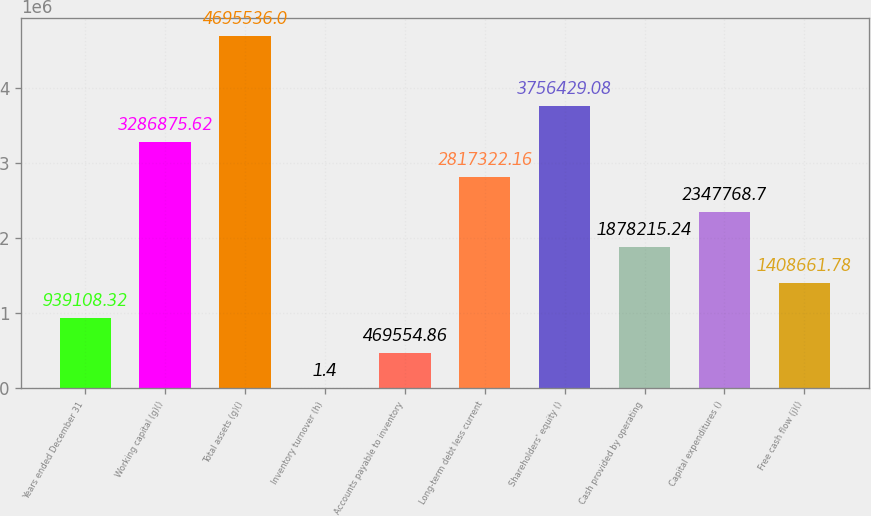Convert chart to OTSL. <chart><loc_0><loc_0><loc_500><loc_500><bar_chart><fcel>Years ended December 31<fcel>Working capital (g)()<fcel>Total assets (g)()<fcel>Inventory turnover (h)<fcel>Accounts payable to inventory<fcel>Long-term debt less current<fcel>Shareholders' equity ()<fcel>Cash provided by operating<fcel>Capital expenditures ()<fcel>Free cash flow (j)()<nl><fcel>939108<fcel>3.28688e+06<fcel>4.69554e+06<fcel>1.4<fcel>469555<fcel>2.81732e+06<fcel>3.75643e+06<fcel>1.87822e+06<fcel>2.34777e+06<fcel>1.40866e+06<nl></chart> 